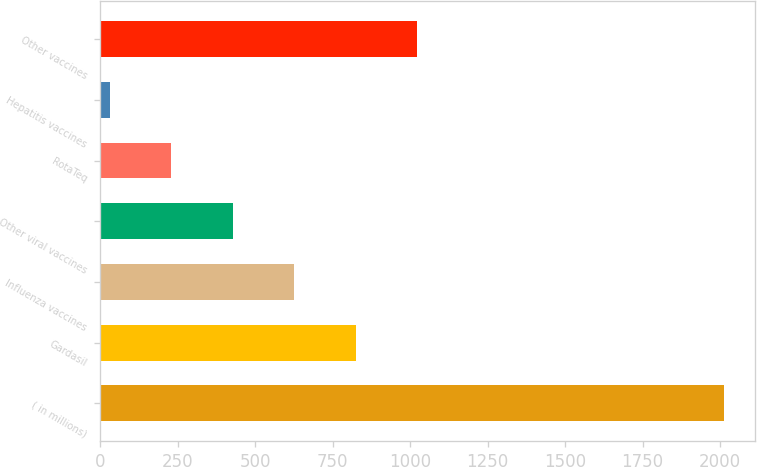Convert chart. <chart><loc_0><loc_0><loc_500><loc_500><bar_chart><fcel>( in millions)<fcel>Gardasil<fcel>Influenza vaccines<fcel>Other viral vaccines<fcel>RotaTeq<fcel>Hepatitis vaccines<fcel>Other vaccines<nl><fcel>2013<fcel>823.8<fcel>625.6<fcel>427.4<fcel>229.2<fcel>31<fcel>1022<nl></chart> 